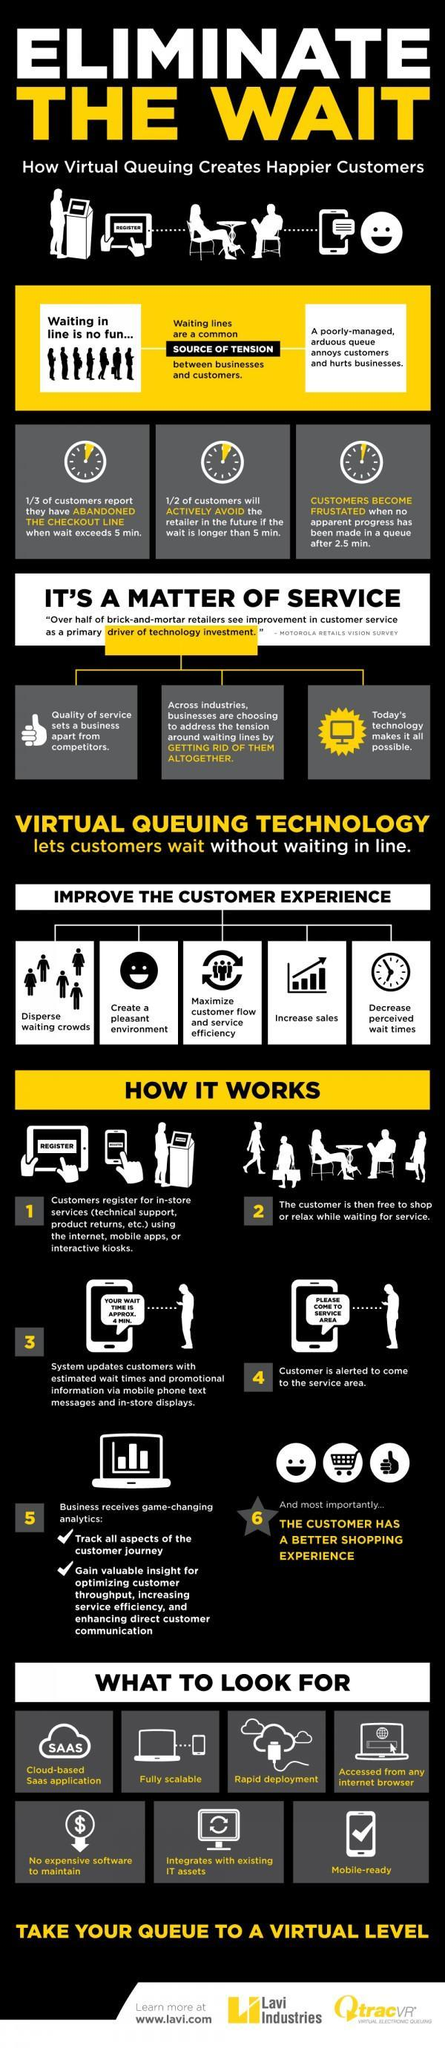what is a common source of tension
Answer the question with a short phrase. waiting lines what is the message in the mobile in the 3rd step your wait time is approx. 4 min. after how much time do customers feel frustrated 2.5 min in which step can all aspects of the customers journey be tracked 5 how many features can be expected in the vitual queuing technology 7 which is the third aspect in improving customer experience maximise customer flow and service efficiency 